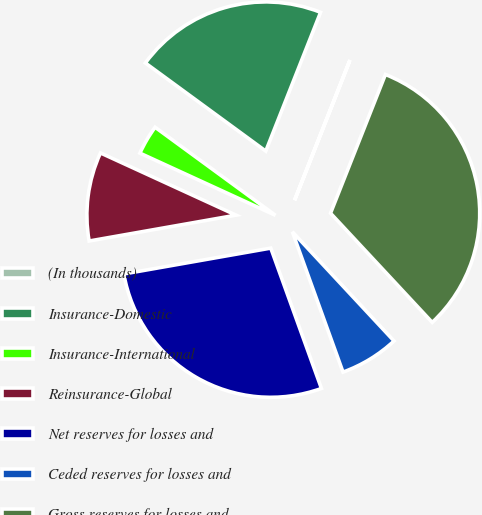<chart> <loc_0><loc_0><loc_500><loc_500><pie_chart><fcel>(In thousands)<fcel>Insurance-Domestic<fcel>Insurance-International<fcel>Reinsurance-Global<fcel>Net reserves for losses and<fcel>Ceded reserves for losses and<fcel>Gross reserves for losses and<nl><fcel>0.01%<fcel>20.93%<fcel>3.21%<fcel>9.62%<fcel>27.74%<fcel>6.42%<fcel>32.07%<nl></chart> 